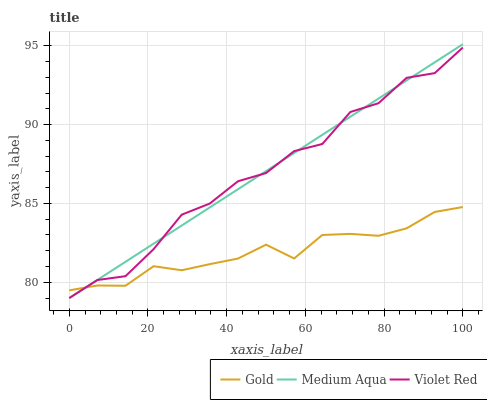Does Medium Aqua have the minimum area under the curve?
Answer yes or no. No. Does Gold have the maximum area under the curve?
Answer yes or no. No. Is Gold the smoothest?
Answer yes or no. No. Is Gold the roughest?
Answer yes or no. No. Does Gold have the lowest value?
Answer yes or no. No. Does Gold have the highest value?
Answer yes or no. No. 